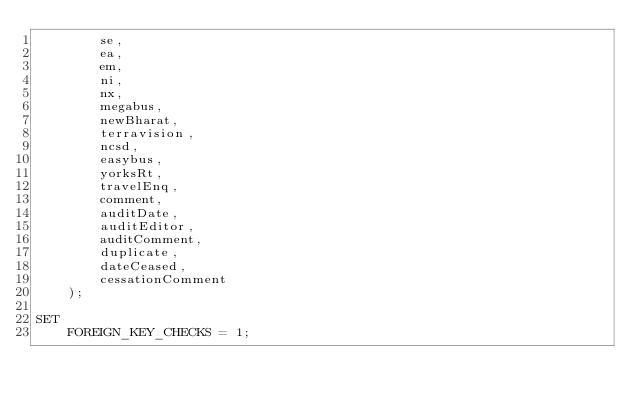<code> <loc_0><loc_0><loc_500><loc_500><_SQL_>        se,
        ea,
        em,
        ni,
        nx,
        megabus,
        newBharat,
        terravision,
        ncsd,
        easybus,
        yorksRt,
        travelEnq,
        comment,
        auditDate,
        auditEditor,
        auditComment,
        duplicate,
        dateCeased,
        cessationComment
    );

SET
    FOREIGN_KEY_CHECKS = 1;</code> 